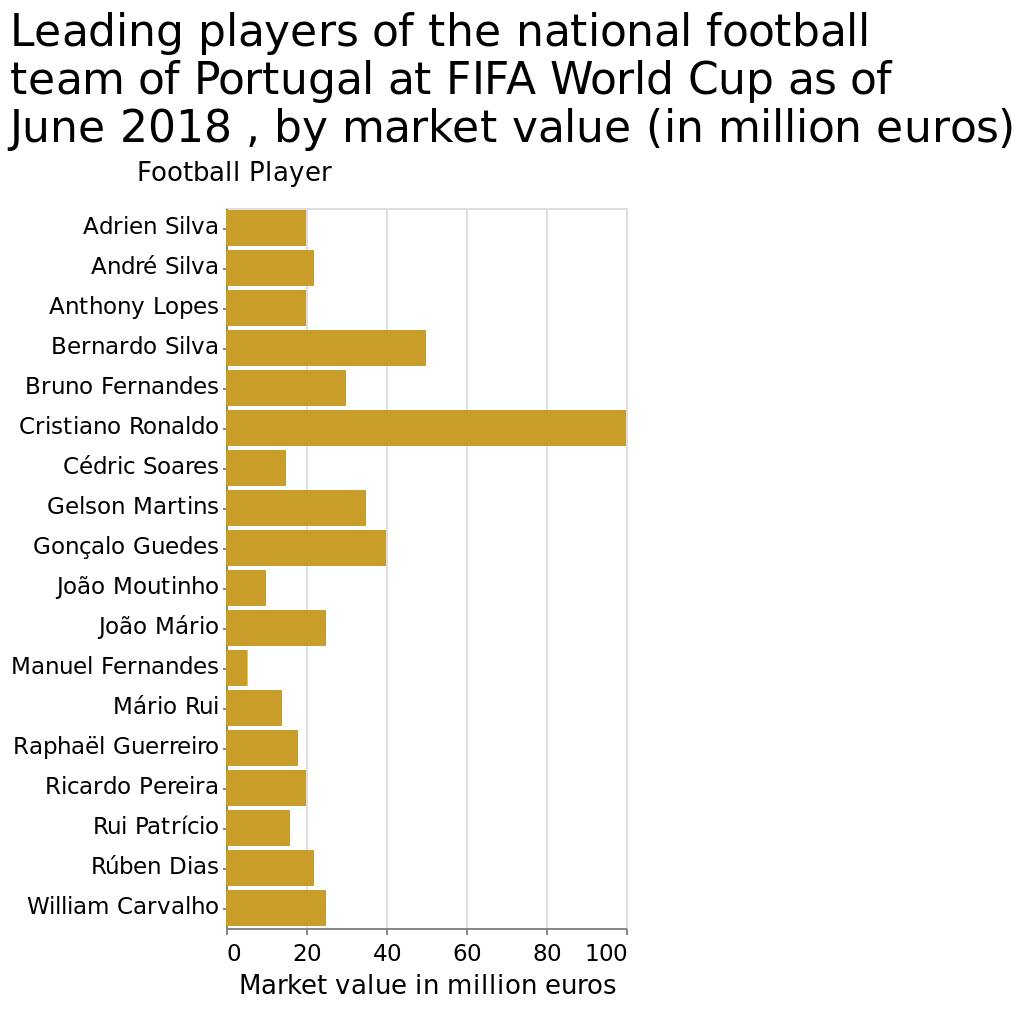<image>
What does the x-axis of the bar chart represent?  The x-axis of the bar chart represents "Market value in million euros." please enumerates aspects of the construction of the chart This is a bar chart named Leading players of the national football team of Portugal at FIFA World Cup as of June 2018 , by market value (in million euros). The y-axis plots Football Player while the x-axis plots Market value in million euros. What is the time period mentioned in the bar chart?  The bar chart shows data as of June 2018. What is the name of the bar chart?  The bar chart is named "Leading players of the national football team of Portugal at FIFA World Cup as of June 2018, by market value (in million euros)." Does the x-axis of the bar chart represent "Number of units sold"? No. The x-axis of the bar chart represents "Market value in million euros." 